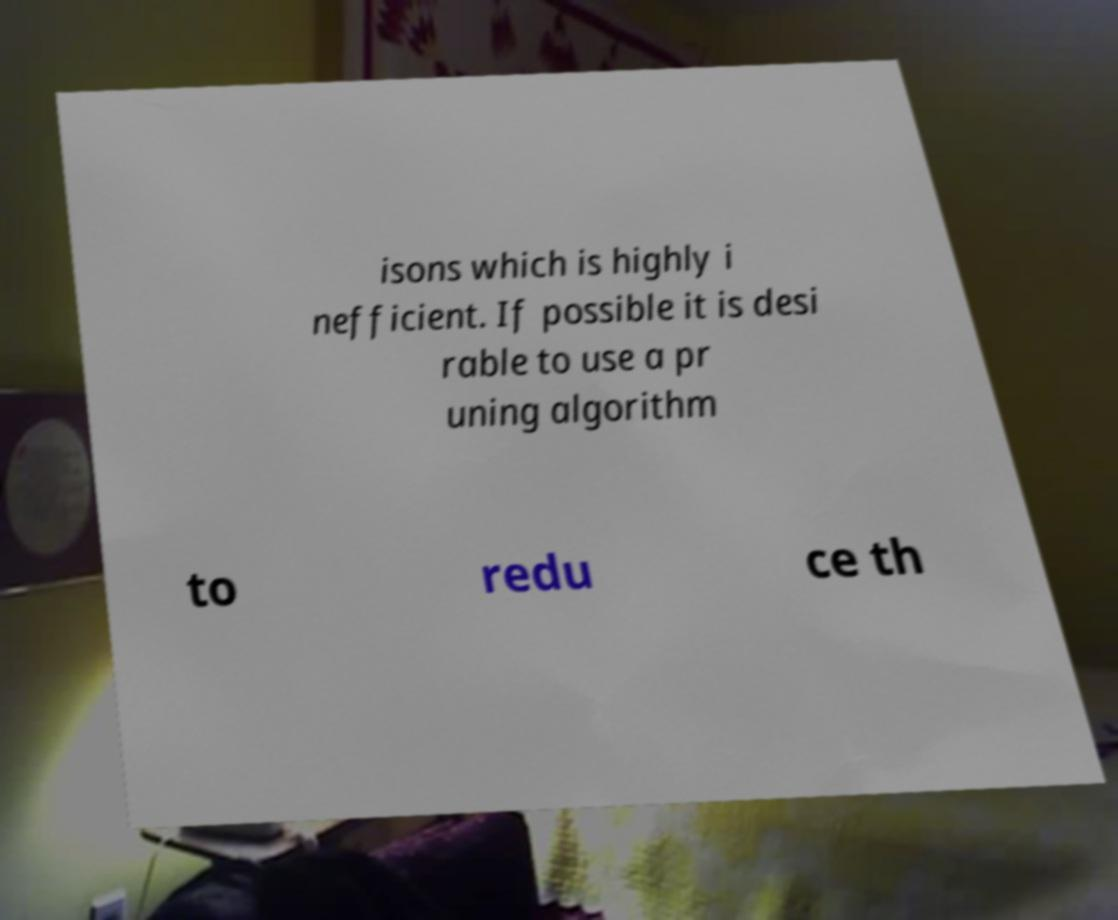For documentation purposes, I need the text within this image transcribed. Could you provide that? isons which is highly i nefficient. If possible it is desi rable to use a pr uning algorithm to redu ce th 